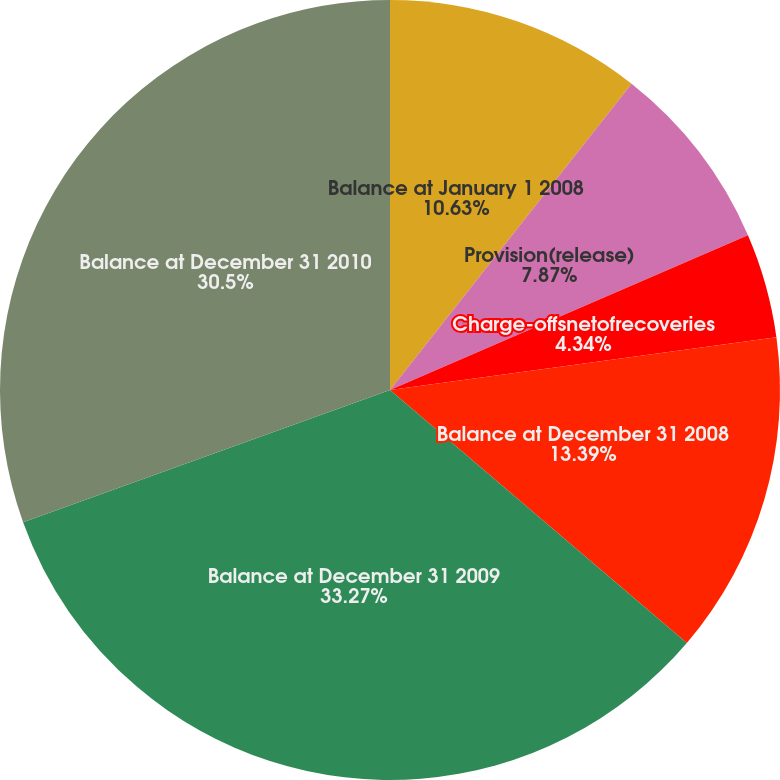Convert chart. <chart><loc_0><loc_0><loc_500><loc_500><pie_chart><fcel>Balance at January 1 2008<fcel>Provision(release)<fcel>Charge-offsnetofrecoveries<fcel>Balance at December 31 2008<fcel>Balance at December 31 2009<fcel>Balance at December 31 2010<nl><fcel>10.63%<fcel>7.87%<fcel>4.34%<fcel>13.39%<fcel>33.26%<fcel>30.5%<nl></chart> 